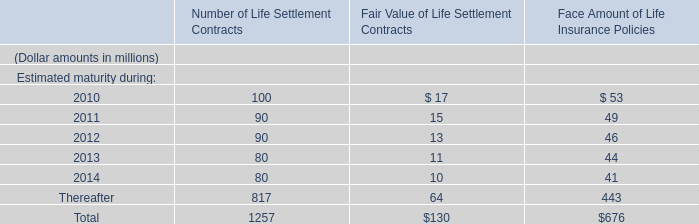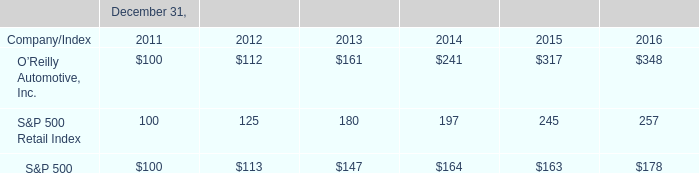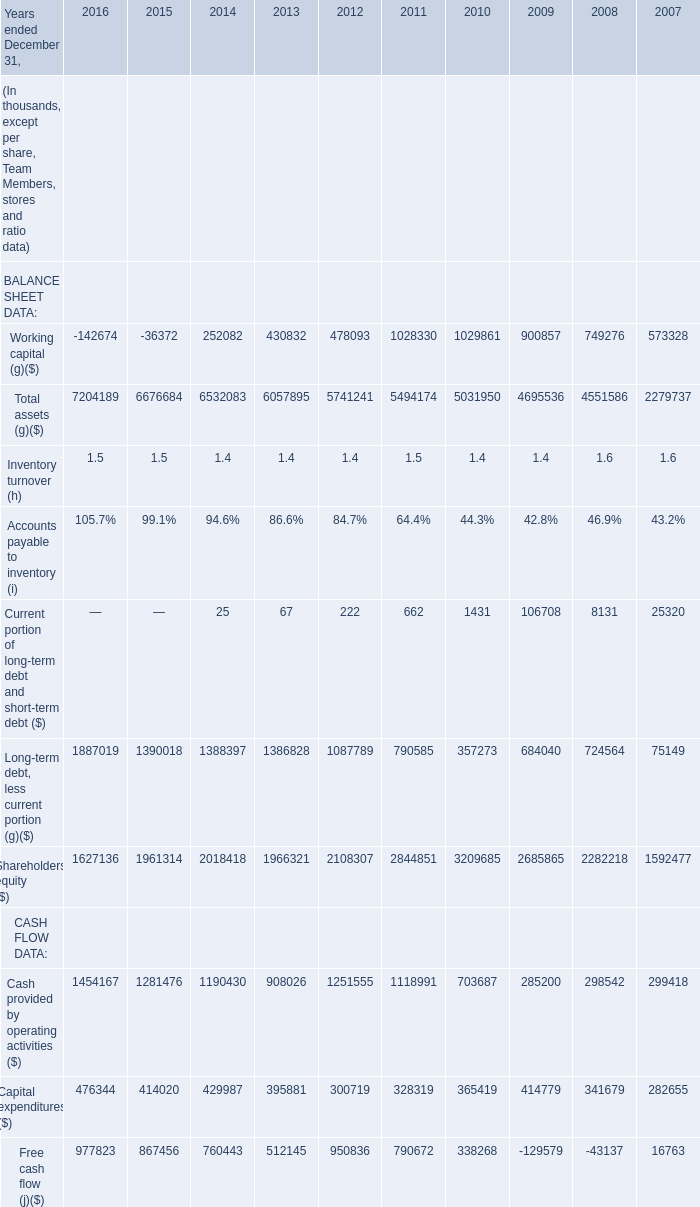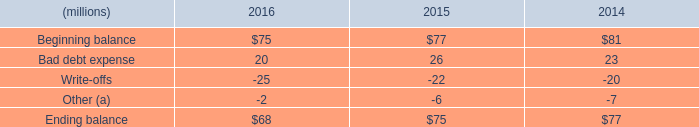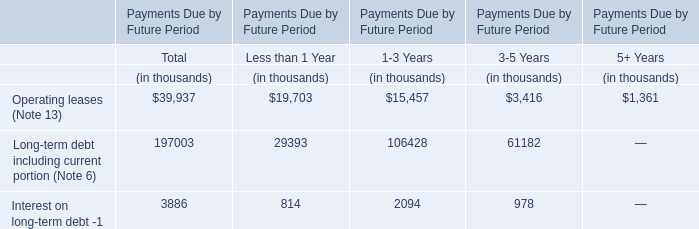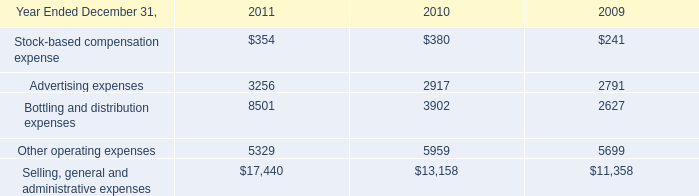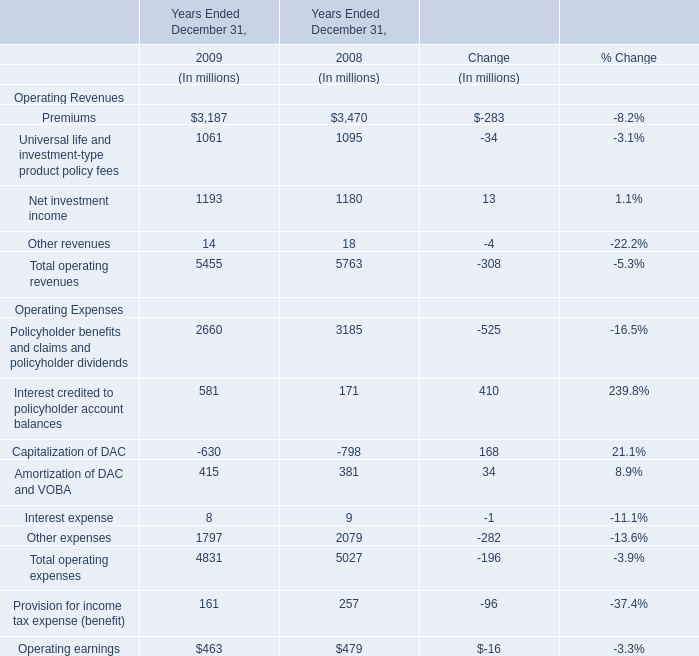In the year with lowest amount of Capitalization of DAC the lowest?, what's the increasing rate of Interest credited to policyholder account balances? 
Computations: ((581 - 171) / 171)
Answer: 2.39766. 